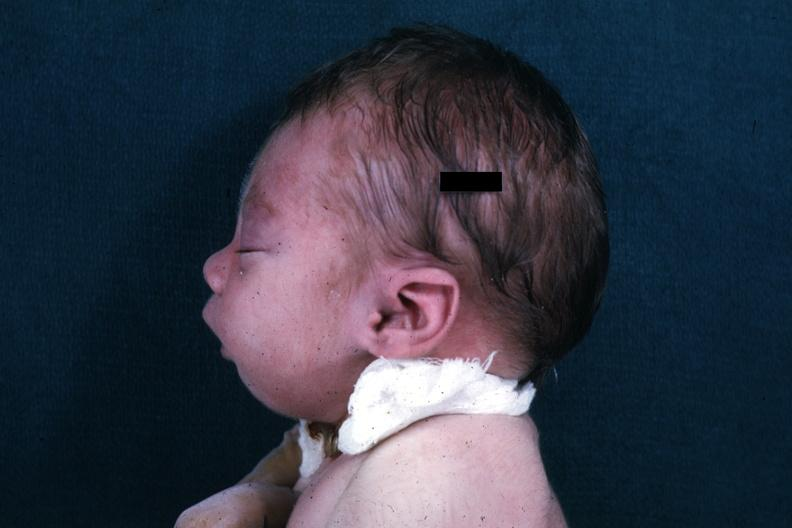does this image show lateral view of infants head showing mandibular lesion?
Answer the question using a single word or phrase. Yes 